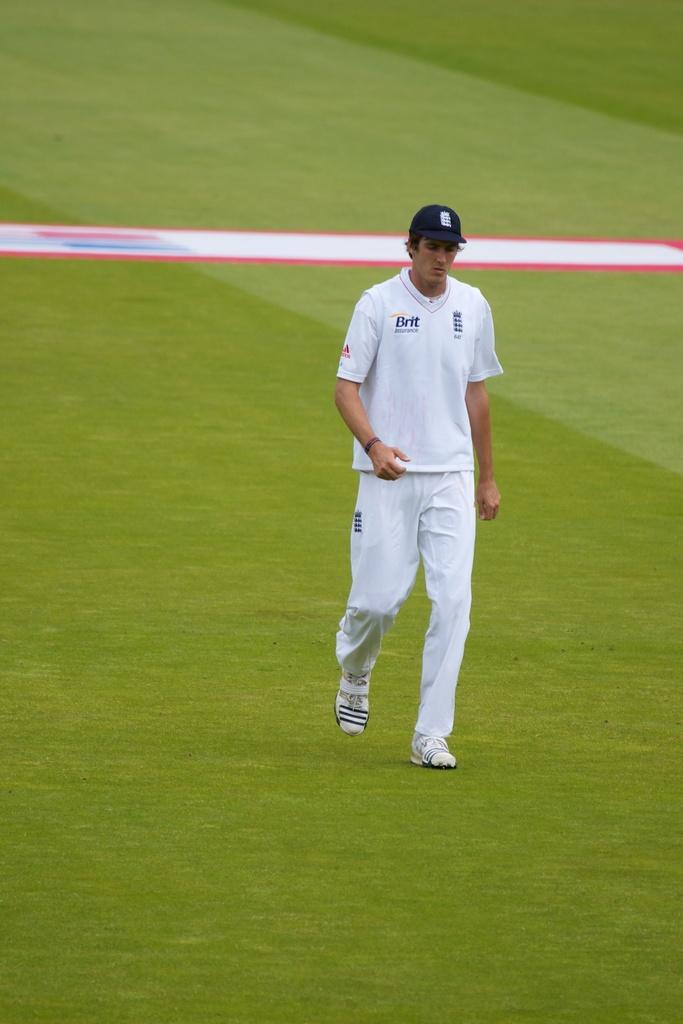Who or what is the main subject in the image? There is a person in the image. What is the person wearing on their head? The person is wearing a hat. What type of surface is the person standing on? The person is standing on the grass. What type of eggnog is the person holding in the image? There is no eggnog present in the image; the person is wearing a hat and standing on the grass. 